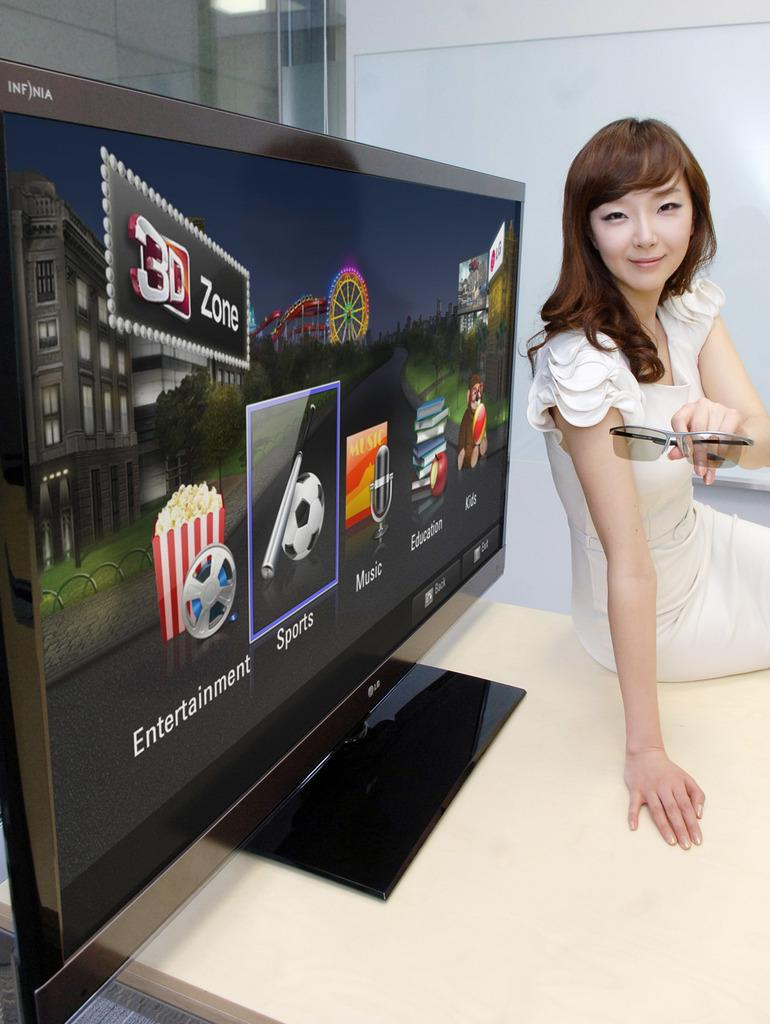<image>
Relay a brief, clear account of the picture shown. A television screen with several icons for Entertainment, Sports, Music, Education and Kids. 